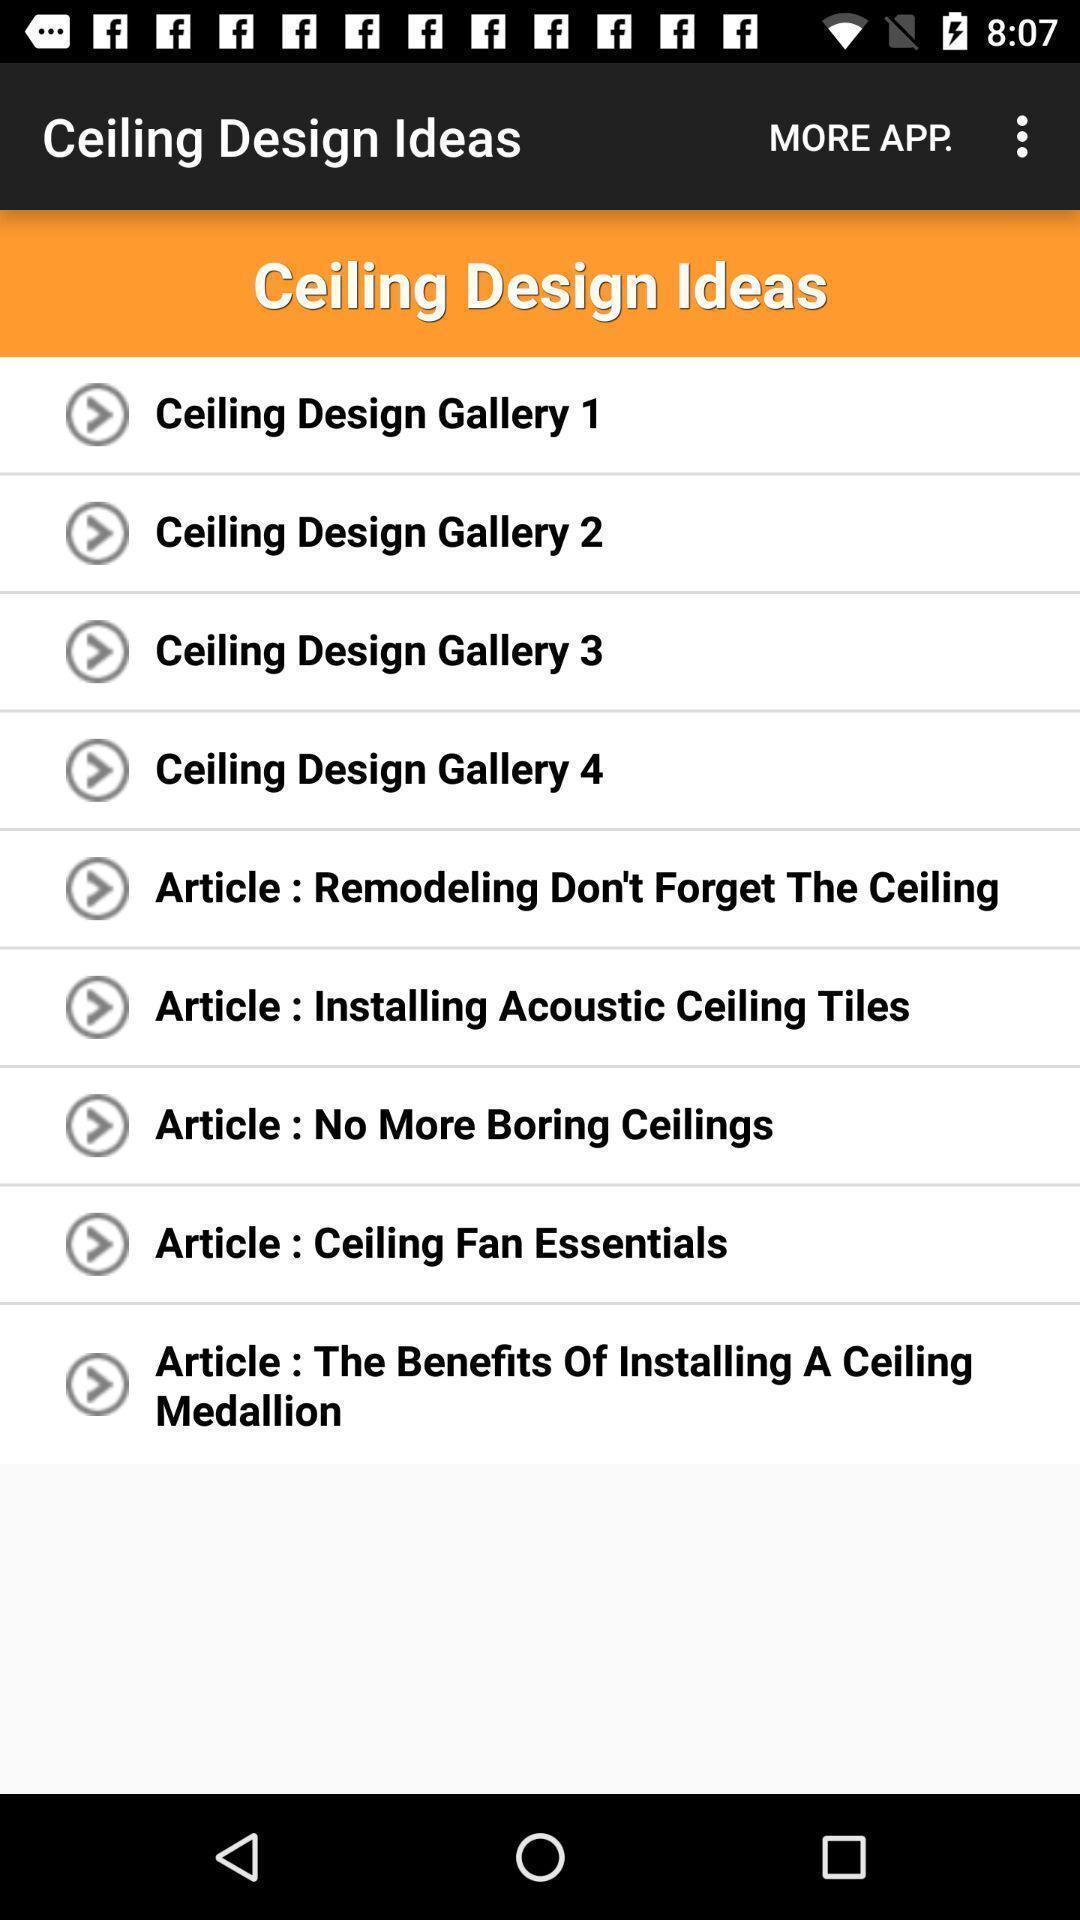Provide a description of this screenshot. Various ideas displayed in a design decoration app. 